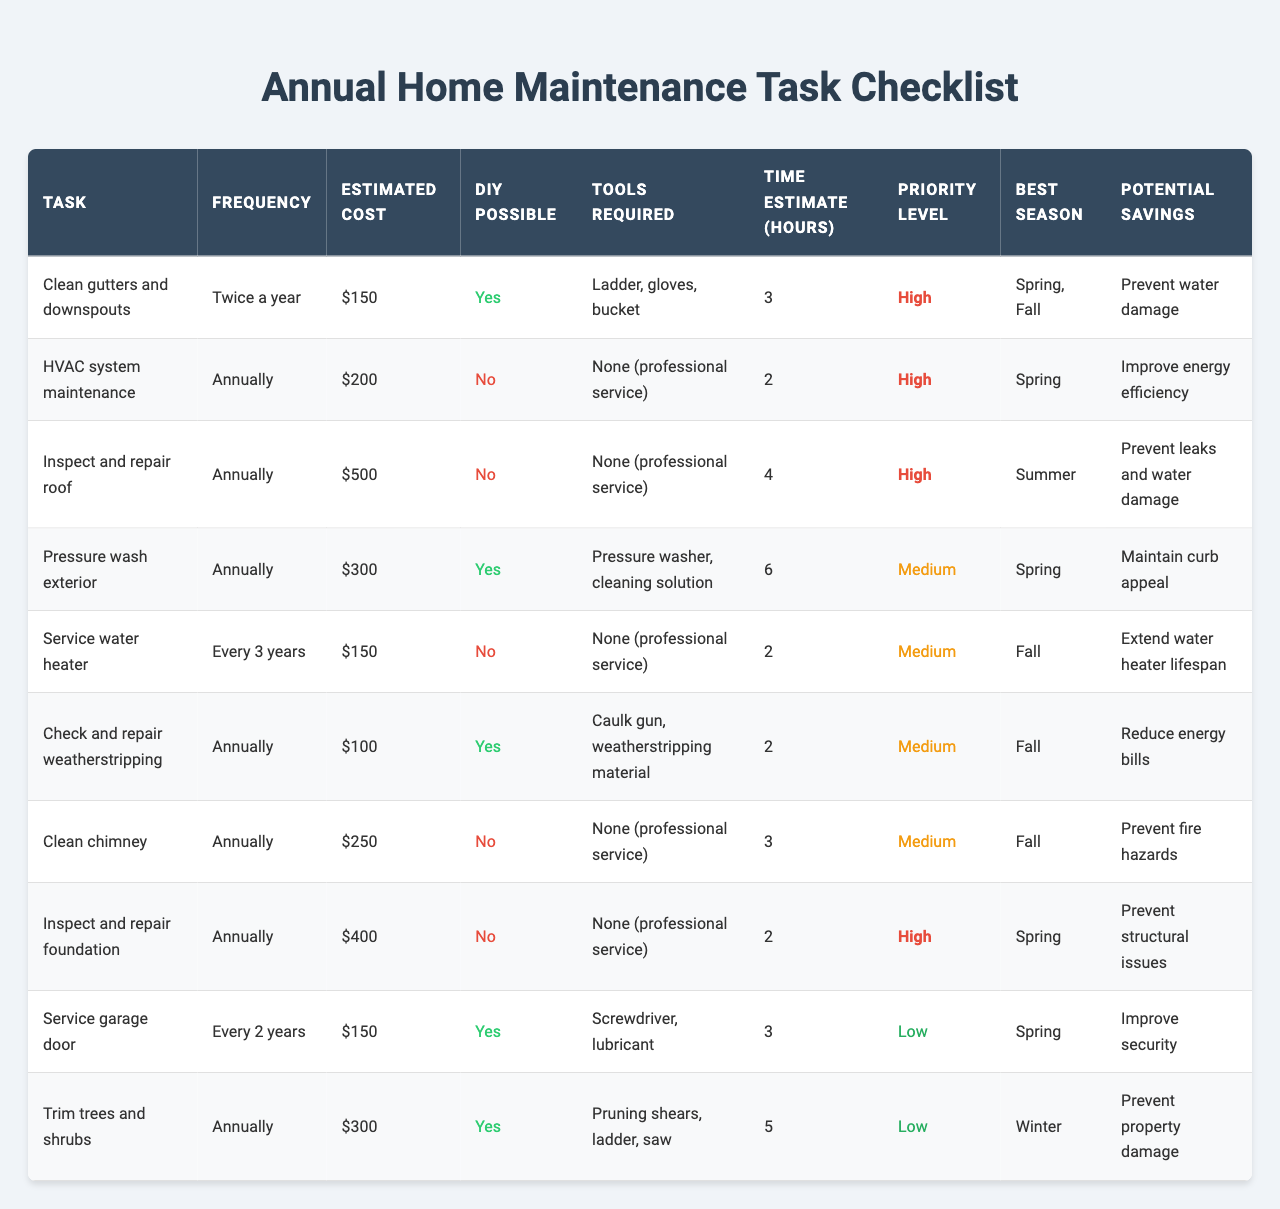What is the estimated cost of cleaning gutters and downspouts? The table lists "Clean gutters and downspouts" under the "Task" column, with an associated "Estimated Cost" of $150.
Answer: $150 How many tasks require professional service? By examining the "DIY Possible" column, three tasks indicate "No," which means they require professional service.
Answer: 3 What is the total estimated cost for all maintenance tasks? Summing the estimated costs: 150 + 200 + 500 + 300 + 150 + 100 + 250 + 400 + 150 + 300 = 2100.
Answer: $2100 Which tasks have a high priority level? The "Priority Level" column shows that the tasks "Clean gutters and downspouts," "HVAC system maintenance," "Inspect and repair roof," and "Inspect and repair foundation" are marked as high priority.
Answer: 4 What is the average time estimate for tasks that can be done by yourself? The DIY tasks and their time estimates are: 3 (gutters), 6 (pressure wash), 2 (weatherstripping), 3 (garage door), and 5 (trimming). The average is (3 + 6 + 2 + 3 + 5) / 5 = 3.8 hours.
Answer: 3.8 hours Which task has the highest cost, and what is that cost? In the "Estimated Cost" column, "Inspect and repair roof" is the highest value listed at $500.
Answer: $500 What is the potential saving for servicing the water heater? The potential saving for "Service water heater" is listed as "Extend water heater lifespan."
Answer: Extend water heater lifespan How many tasks should be performed in the fall? The "Best Season" column indicates that the following tasks are best performed in the fall: "Service water heater," "Check and repair weatherstripping," "Clean chimney," and "Inspect and repair foundation." This totals 4 tasks.
Answer: 4 What are the tools required for pressure washing the exterior? According to the "Tools Required" column, the tools needed are "Pressure washer, cleaning solution."
Answer: Pressure washer, cleaning solution Is it possible to perform DIY maintenance on HVAC system maintenance? The "DIY Possible" column indicates "No" for HVAC system maintenance, meaning it cannot be done as a DIY task.
Answer: No Which task has the lowest priority level? The table shows that both "Service garage door" and "Trim trees and shrubs" have a "Low" priority level.
Answer: Service garage door and Trim trees and shrubs 